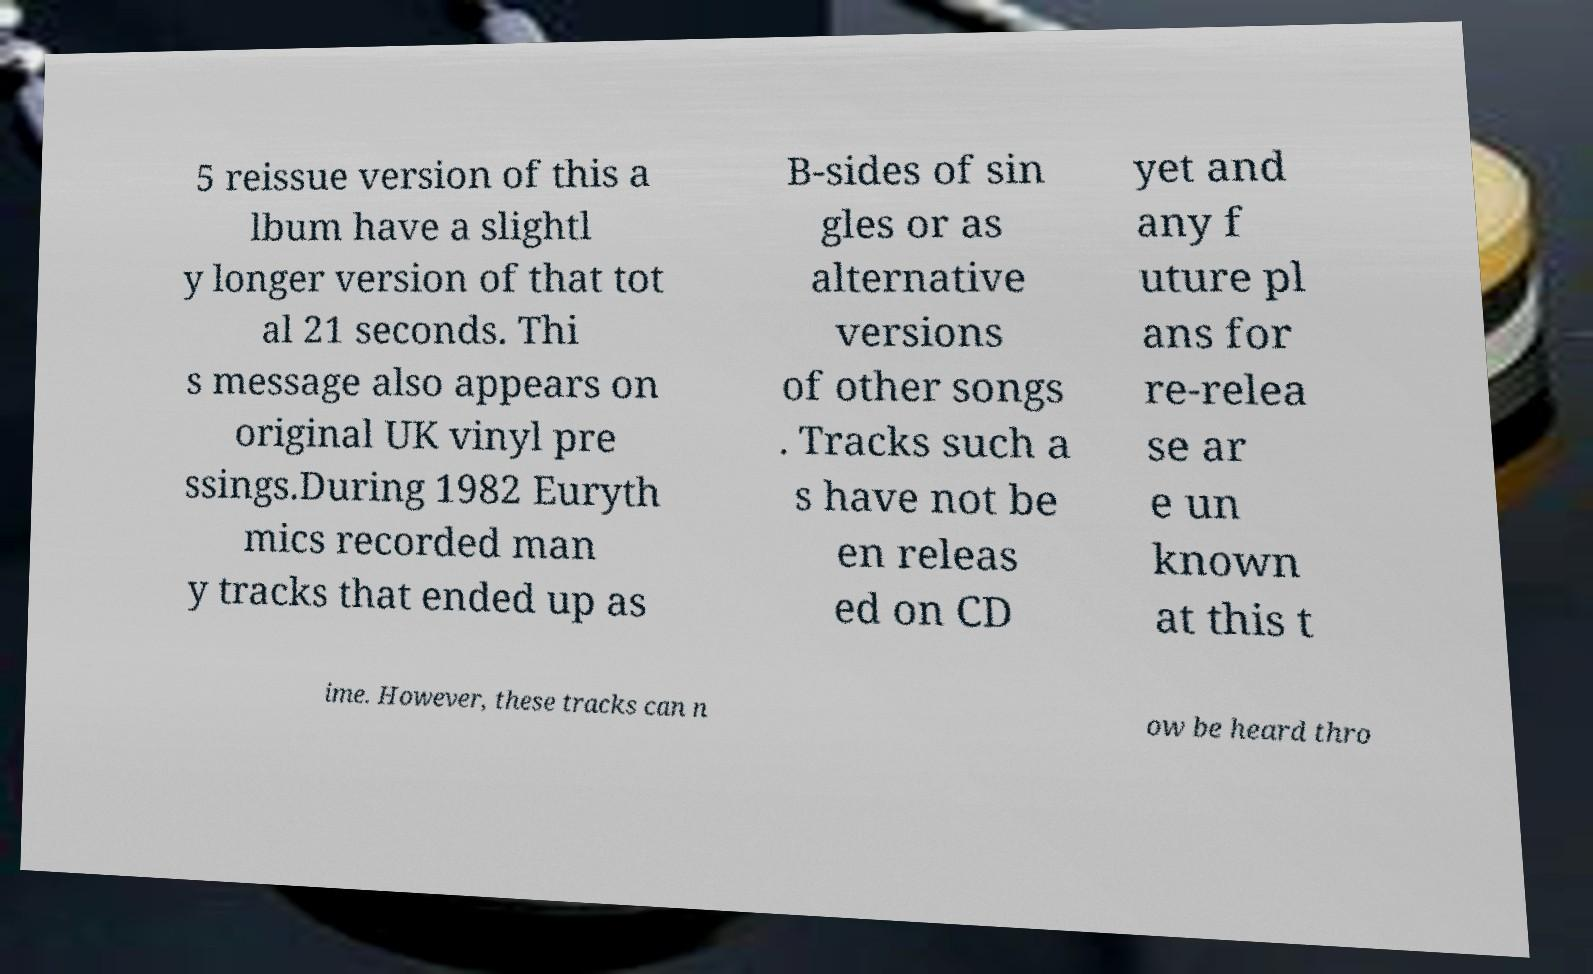Can you read and provide the text displayed in the image?This photo seems to have some interesting text. Can you extract and type it out for me? 5 reissue version of this a lbum have a slightl y longer version of that tot al 21 seconds. Thi s message also appears on original UK vinyl pre ssings.During 1982 Euryth mics recorded man y tracks that ended up as B-sides of sin gles or as alternative versions of other songs . Tracks such a s have not be en releas ed on CD yet and any f uture pl ans for re-relea se ar e un known at this t ime. However, these tracks can n ow be heard thro 